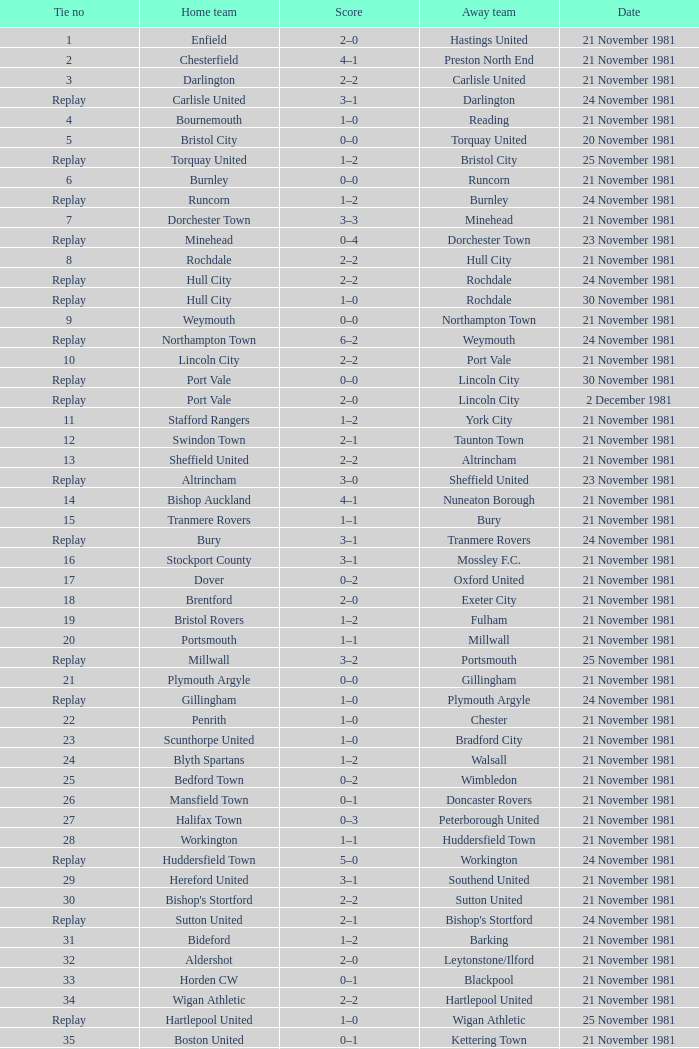What tie numeral does minehead have? Replay. 